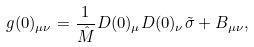Convert formula to latex. <formula><loc_0><loc_0><loc_500><loc_500>g ( 0 ) _ { \mu \nu } = \frac { 1 } { \hat { M } } D ( 0 ) _ { \mu } D ( 0 ) _ { \nu } \tilde { \sigma } + B _ { \mu \nu } ,</formula> 